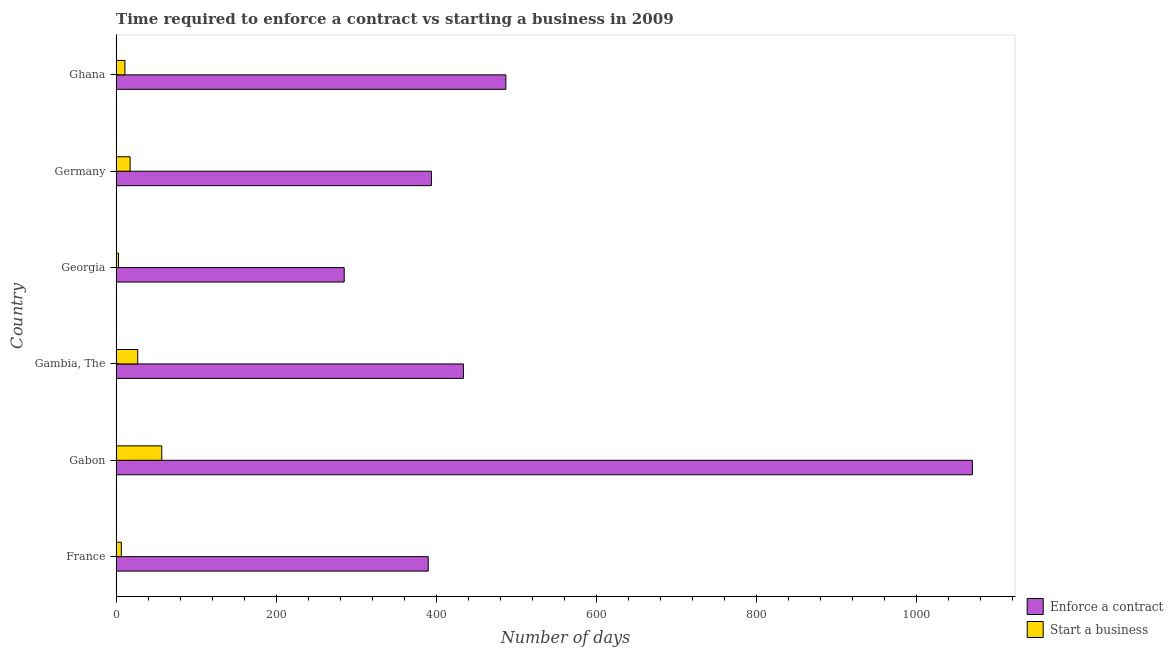Are the number of bars on each tick of the Y-axis equal?
Your answer should be very brief. Yes. What is the label of the 1st group of bars from the top?
Your answer should be compact. Ghana. In how many cases, is the number of bars for a given country not equal to the number of legend labels?
Offer a terse response. 0. What is the number of days to start a business in Gabon?
Provide a short and direct response. 57. Across all countries, what is the minimum number of days to start a business?
Keep it short and to the point. 3. In which country was the number of days to start a business maximum?
Ensure brevity in your answer.  Gabon. In which country was the number of days to start a business minimum?
Offer a terse response. Georgia. What is the total number of days to enforece a contract in the graph?
Ensure brevity in your answer.  3060. What is the difference between the number of days to enforece a contract in France and that in Ghana?
Offer a very short reply. -97. What is the difference between the number of days to enforece a contract in Georgia and the number of days to start a business in Germany?
Provide a succinct answer. 267.5. What is the average number of days to enforece a contract per country?
Make the answer very short. 510. What is the difference between the number of days to enforece a contract and number of days to start a business in Germany?
Make the answer very short. 376.5. What is the ratio of the number of days to start a business in France to that in Gabon?
Provide a short and direct response. 0.11. Is the number of days to start a business in France less than that in Ghana?
Offer a terse response. Yes. Is the difference between the number of days to enforece a contract in Gambia, The and Georgia greater than the difference between the number of days to start a business in Gambia, The and Georgia?
Offer a terse response. Yes. What is the difference between the highest and the second highest number of days to start a business?
Provide a short and direct response. 30. What is the difference between the highest and the lowest number of days to enforece a contract?
Make the answer very short. 785. What does the 2nd bar from the top in Gabon represents?
Your answer should be compact. Enforce a contract. What does the 2nd bar from the bottom in Georgia represents?
Provide a succinct answer. Start a business. How many bars are there?
Make the answer very short. 12. How many countries are there in the graph?
Your answer should be compact. 6. What is the difference between two consecutive major ticks on the X-axis?
Your answer should be very brief. 200. How many legend labels are there?
Your answer should be very brief. 2. How are the legend labels stacked?
Your answer should be compact. Vertical. What is the title of the graph?
Provide a short and direct response. Time required to enforce a contract vs starting a business in 2009. What is the label or title of the X-axis?
Make the answer very short. Number of days. What is the label or title of the Y-axis?
Offer a very short reply. Country. What is the Number of days in Enforce a contract in France?
Give a very brief answer. 390. What is the Number of days of Enforce a contract in Gabon?
Provide a short and direct response. 1070. What is the Number of days of Start a business in Gabon?
Provide a succinct answer. 57. What is the Number of days of Enforce a contract in Gambia, The?
Provide a short and direct response. 434. What is the Number of days of Start a business in Gambia, The?
Keep it short and to the point. 27. What is the Number of days of Enforce a contract in Georgia?
Your answer should be compact. 285. What is the Number of days of Start a business in Georgia?
Offer a very short reply. 3. What is the Number of days of Enforce a contract in Germany?
Offer a terse response. 394. What is the Number of days in Start a business in Germany?
Provide a short and direct response. 17.5. What is the Number of days in Enforce a contract in Ghana?
Keep it short and to the point. 487. What is the Number of days of Start a business in Ghana?
Your answer should be compact. 11. Across all countries, what is the maximum Number of days in Enforce a contract?
Offer a terse response. 1070. Across all countries, what is the minimum Number of days in Enforce a contract?
Your answer should be compact. 285. What is the total Number of days of Enforce a contract in the graph?
Offer a terse response. 3060. What is the total Number of days of Start a business in the graph?
Your response must be concise. 122. What is the difference between the Number of days of Enforce a contract in France and that in Gabon?
Give a very brief answer. -680. What is the difference between the Number of days of Start a business in France and that in Gabon?
Provide a succinct answer. -50.5. What is the difference between the Number of days of Enforce a contract in France and that in Gambia, The?
Provide a succinct answer. -44. What is the difference between the Number of days in Start a business in France and that in Gambia, The?
Keep it short and to the point. -20.5. What is the difference between the Number of days in Enforce a contract in France and that in Georgia?
Ensure brevity in your answer.  105. What is the difference between the Number of days of Start a business in France and that in Georgia?
Your response must be concise. 3.5. What is the difference between the Number of days of Start a business in France and that in Germany?
Provide a short and direct response. -11. What is the difference between the Number of days of Enforce a contract in France and that in Ghana?
Provide a succinct answer. -97. What is the difference between the Number of days in Enforce a contract in Gabon and that in Gambia, The?
Keep it short and to the point. 636. What is the difference between the Number of days in Start a business in Gabon and that in Gambia, The?
Give a very brief answer. 30. What is the difference between the Number of days of Enforce a contract in Gabon and that in Georgia?
Provide a succinct answer. 785. What is the difference between the Number of days in Enforce a contract in Gabon and that in Germany?
Give a very brief answer. 676. What is the difference between the Number of days in Start a business in Gabon and that in Germany?
Offer a terse response. 39.5. What is the difference between the Number of days in Enforce a contract in Gabon and that in Ghana?
Provide a succinct answer. 583. What is the difference between the Number of days in Enforce a contract in Gambia, The and that in Georgia?
Offer a very short reply. 149. What is the difference between the Number of days of Enforce a contract in Gambia, The and that in Germany?
Offer a very short reply. 40. What is the difference between the Number of days in Enforce a contract in Gambia, The and that in Ghana?
Make the answer very short. -53. What is the difference between the Number of days in Enforce a contract in Georgia and that in Germany?
Your answer should be compact. -109. What is the difference between the Number of days in Enforce a contract in Georgia and that in Ghana?
Give a very brief answer. -202. What is the difference between the Number of days of Enforce a contract in Germany and that in Ghana?
Your response must be concise. -93. What is the difference between the Number of days of Enforce a contract in France and the Number of days of Start a business in Gabon?
Provide a short and direct response. 333. What is the difference between the Number of days in Enforce a contract in France and the Number of days in Start a business in Gambia, The?
Offer a very short reply. 363. What is the difference between the Number of days of Enforce a contract in France and the Number of days of Start a business in Georgia?
Give a very brief answer. 387. What is the difference between the Number of days in Enforce a contract in France and the Number of days in Start a business in Germany?
Your answer should be very brief. 372.5. What is the difference between the Number of days in Enforce a contract in France and the Number of days in Start a business in Ghana?
Offer a terse response. 379. What is the difference between the Number of days in Enforce a contract in Gabon and the Number of days in Start a business in Gambia, The?
Provide a short and direct response. 1043. What is the difference between the Number of days of Enforce a contract in Gabon and the Number of days of Start a business in Georgia?
Offer a terse response. 1067. What is the difference between the Number of days in Enforce a contract in Gabon and the Number of days in Start a business in Germany?
Your answer should be very brief. 1052.5. What is the difference between the Number of days in Enforce a contract in Gabon and the Number of days in Start a business in Ghana?
Offer a very short reply. 1059. What is the difference between the Number of days of Enforce a contract in Gambia, The and the Number of days of Start a business in Georgia?
Give a very brief answer. 431. What is the difference between the Number of days in Enforce a contract in Gambia, The and the Number of days in Start a business in Germany?
Keep it short and to the point. 416.5. What is the difference between the Number of days in Enforce a contract in Gambia, The and the Number of days in Start a business in Ghana?
Make the answer very short. 423. What is the difference between the Number of days in Enforce a contract in Georgia and the Number of days in Start a business in Germany?
Offer a terse response. 267.5. What is the difference between the Number of days of Enforce a contract in Georgia and the Number of days of Start a business in Ghana?
Give a very brief answer. 274. What is the difference between the Number of days of Enforce a contract in Germany and the Number of days of Start a business in Ghana?
Offer a very short reply. 383. What is the average Number of days of Enforce a contract per country?
Ensure brevity in your answer.  510. What is the average Number of days of Start a business per country?
Make the answer very short. 20.33. What is the difference between the Number of days in Enforce a contract and Number of days in Start a business in France?
Your answer should be very brief. 383.5. What is the difference between the Number of days in Enforce a contract and Number of days in Start a business in Gabon?
Provide a short and direct response. 1013. What is the difference between the Number of days of Enforce a contract and Number of days of Start a business in Gambia, The?
Provide a succinct answer. 407. What is the difference between the Number of days of Enforce a contract and Number of days of Start a business in Georgia?
Keep it short and to the point. 282. What is the difference between the Number of days in Enforce a contract and Number of days in Start a business in Germany?
Your answer should be very brief. 376.5. What is the difference between the Number of days in Enforce a contract and Number of days in Start a business in Ghana?
Offer a terse response. 476. What is the ratio of the Number of days of Enforce a contract in France to that in Gabon?
Your response must be concise. 0.36. What is the ratio of the Number of days of Start a business in France to that in Gabon?
Give a very brief answer. 0.11. What is the ratio of the Number of days of Enforce a contract in France to that in Gambia, The?
Give a very brief answer. 0.9. What is the ratio of the Number of days in Start a business in France to that in Gambia, The?
Give a very brief answer. 0.24. What is the ratio of the Number of days in Enforce a contract in France to that in Georgia?
Ensure brevity in your answer.  1.37. What is the ratio of the Number of days in Start a business in France to that in Georgia?
Provide a short and direct response. 2.17. What is the ratio of the Number of days of Enforce a contract in France to that in Germany?
Your response must be concise. 0.99. What is the ratio of the Number of days in Start a business in France to that in Germany?
Keep it short and to the point. 0.37. What is the ratio of the Number of days of Enforce a contract in France to that in Ghana?
Provide a succinct answer. 0.8. What is the ratio of the Number of days of Start a business in France to that in Ghana?
Make the answer very short. 0.59. What is the ratio of the Number of days of Enforce a contract in Gabon to that in Gambia, The?
Make the answer very short. 2.47. What is the ratio of the Number of days of Start a business in Gabon to that in Gambia, The?
Provide a succinct answer. 2.11. What is the ratio of the Number of days of Enforce a contract in Gabon to that in Georgia?
Make the answer very short. 3.75. What is the ratio of the Number of days of Start a business in Gabon to that in Georgia?
Your response must be concise. 19. What is the ratio of the Number of days of Enforce a contract in Gabon to that in Germany?
Offer a terse response. 2.72. What is the ratio of the Number of days in Start a business in Gabon to that in Germany?
Your answer should be very brief. 3.26. What is the ratio of the Number of days in Enforce a contract in Gabon to that in Ghana?
Your response must be concise. 2.2. What is the ratio of the Number of days of Start a business in Gabon to that in Ghana?
Offer a very short reply. 5.18. What is the ratio of the Number of days in Enforce a contract in Gambia, The to that in Georgia?
Keep it short and to the point. 1.52. What is the ratio of the Number of days of Start a business in Gambia, The to that in Georgia?
Your response must be concise. 9. What is the ratio of the Number of days in Enforce a contract in Gambia, The to that in Germany?
Provide a succinct answer. 1.1. What is the ratio of the Number of days of Start a business in Gambia, The to that in Germany?
Offer a terse response. 1.54. What is the ratio of the Number of days in Enforce a contract in Gambia, The to that in Ghana?
Your answer should be very brief. 0.89. What is the ratio of the Number of days of Start a business in Gambia, The to that in Ghana?
Give a very brief answer. 2.45. What is the ratio of the Number of days in Enforce a contract in Georgia to that in Germany?
Make the answer very short. 0.72. What is the ratio of the Number of days of Start a business in Georgia to that in Germany?
Give a very brief answer. 0.17. What is the ratio of the Number of days of Enforce a contract in Georgia to that in Ghana?
Make the answer very short. 0.59. What is the ratio of the Number of days of Start a business in Georgia to that in Ghana?
Provide a succinct answer. 0.27. What is the ratio of the Number of days in Enforce a contract in Germany to that in Ghana?
Offer a terse response. 0.81. What is the ratio of the Number of days of Start a business in Germany to that in Ghana?
Your response must be concise. 1.59. What is the difference between the highest and the second highest Number of days in Enforce a contract?
Your answer should be compact. 583. What is the difference between the highest and the second highest Number of days in Start a business?
Offer a very short reply. 30. What is the difference between the highest and the lowest Number of days in Enforce a contract?
Keep it short and to the point. 785. 